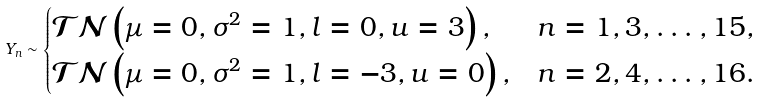<formula> <loc_0><loc_0><loc_500><loc_500>Y _ { n } \sim \begin{cases} \mathcal { T N } \left ( \mu = 0 , \sigma ^ { 2 } = 1 , l = 0 , u = 3 \right ) , & n = 1 , 3 , \dots , 1 5 , \\ \mathcal { T N } \left ( \mu = 0 , \sigma ^ { 2 } = 1 , l = - 3 , u = 0 \right ) , & n = 2 , 4 , \dots , 1 6 . \end{cases}</formula> 